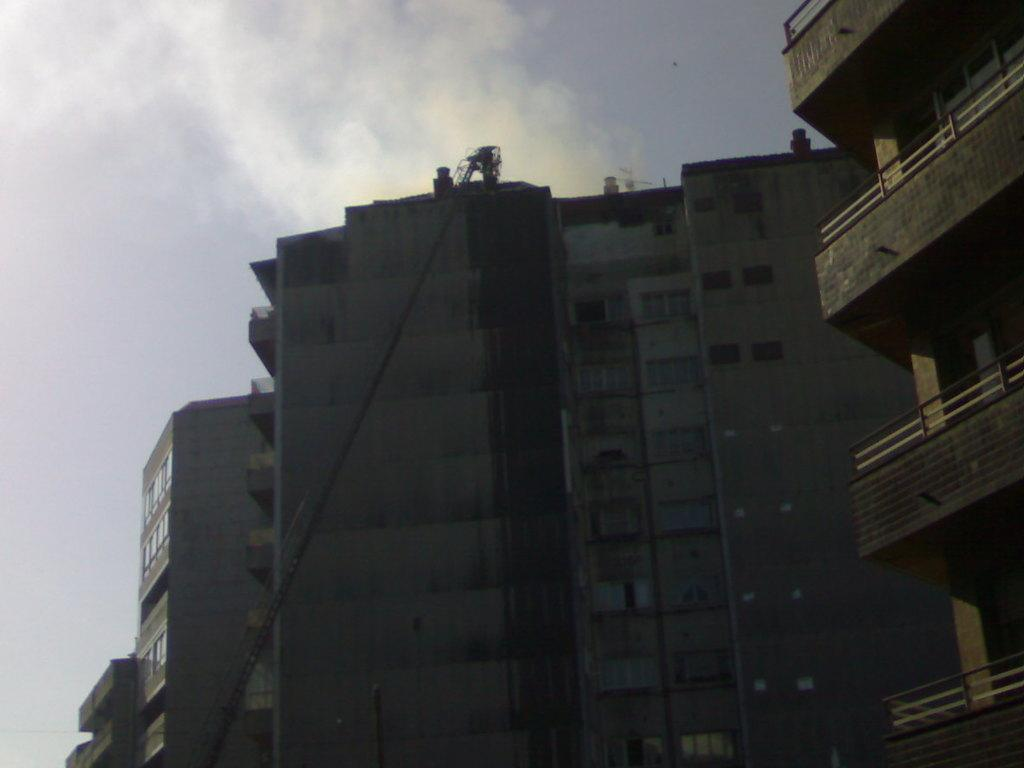What type of structures can be seen in the image? There are buildings in the image. What is the large object with a long arm in the image? There appears to be a crane in the image. What can be seen in the background of the image? The sky is visible in the background of the image. What type of brush can be seen cleaning the buildings in the image? There is no brush present in the image; the focus is on the buildings and the crane. 